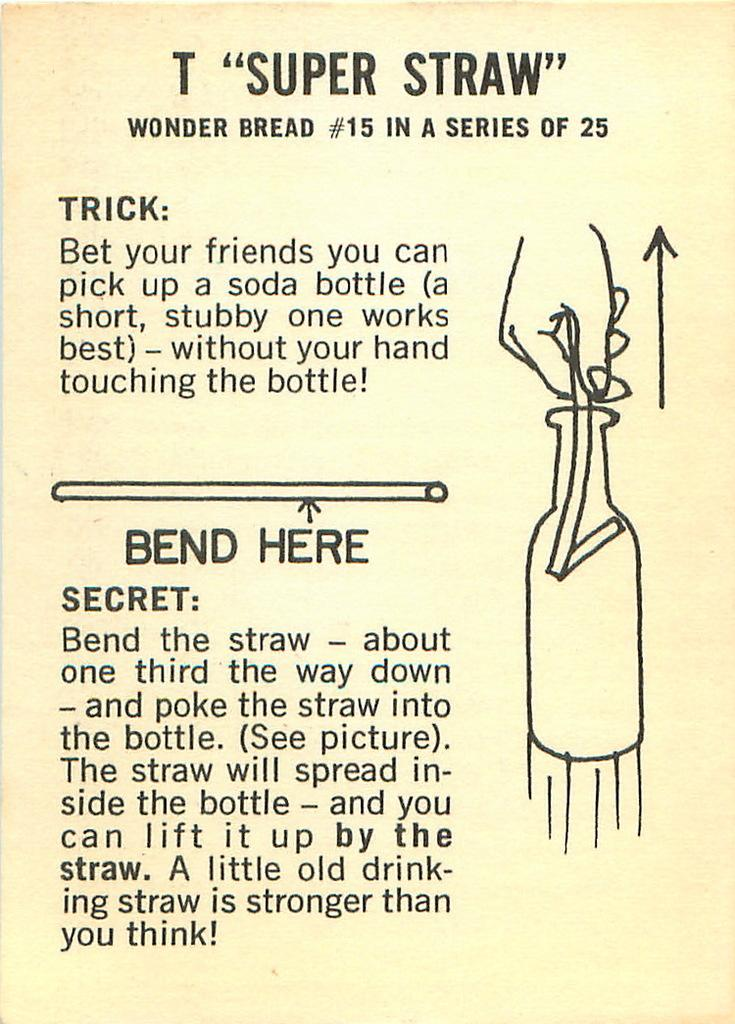Provide a one-sentence caption for the provided image. A super straw magic trick is explained on this flyer which involves lifting a bottle with a straw. 